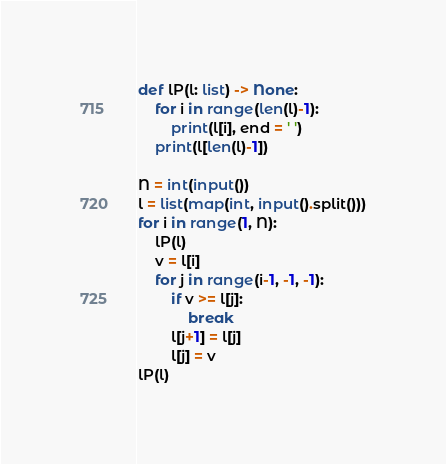Convert code to text. <code><loc_0><loc_0><loc_500><loc_500><_Python_>def lP(l: list) -> None:
    for i in range(len(l)-1):
        print(l[i], end = ' ')
    print(l[len(l)-1])

N = int(input())
l = list(map(int, input().split()))
for i in range(1, N):
    lP(l)
    v = l[i]
    for j in range(i-1, -1, -1):
        if v >= l[j]:
            break
        l[j+1] = l[j]
        l[j] = v
lP(l)
</code> 